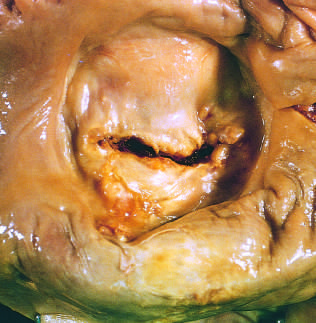s there marked left atrial dilation as seen from above the valve?
Answer the question using a single word or phrase. Yes 